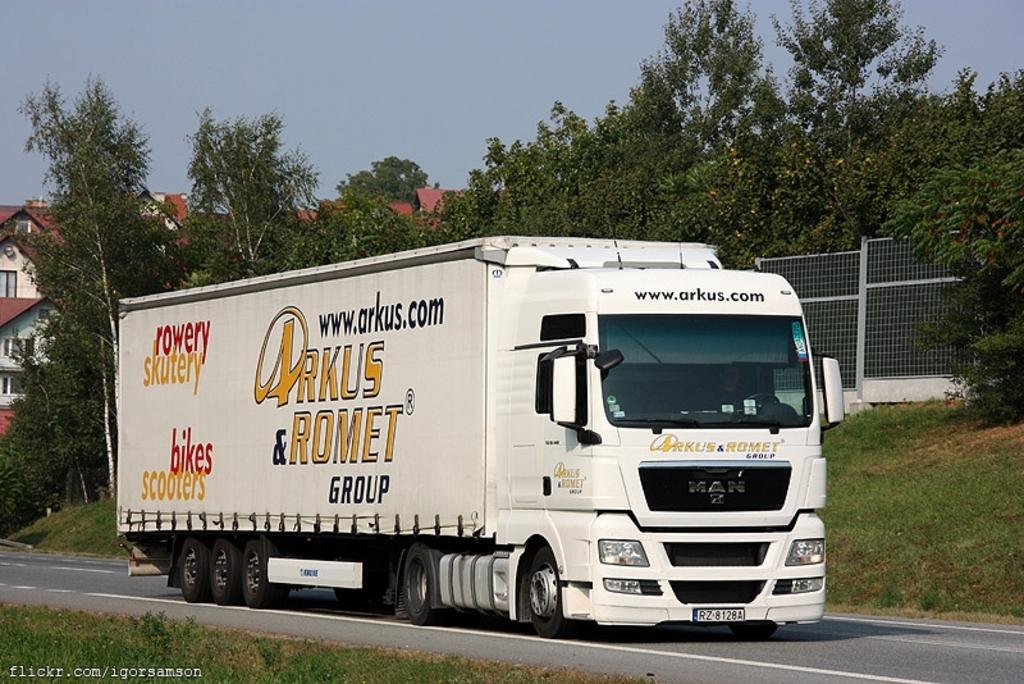In one or two sentences, can you explain what this image depicts? In this picture we can see a truck on the road and behind the truck there is a fence, trees, houses and a sky. On the image there is a watermark. 